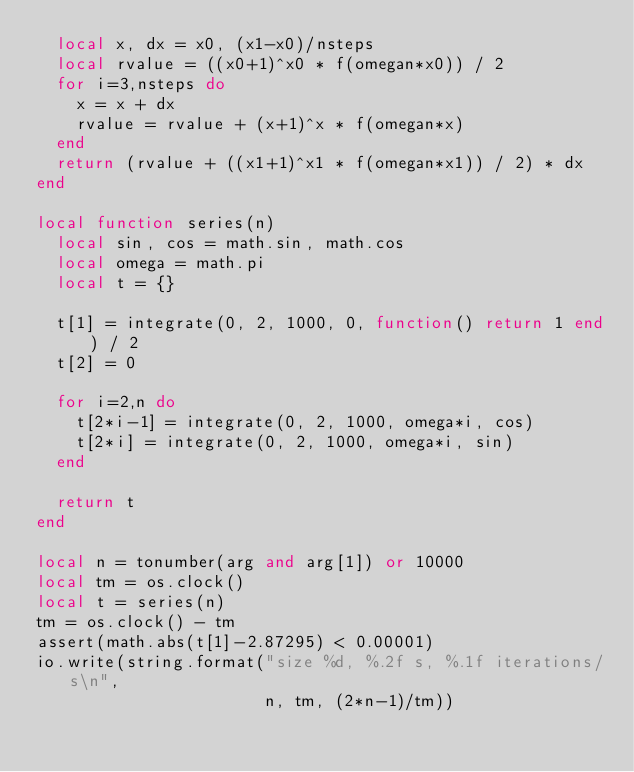<code> <loc_0><loc_0><loc_500><loc_500><_Lua_>  local x, dx = x0, (x1-x0)/nsteps
  local rvalue = ((x0+1)^x0 * f(omegan*x0)) / 2
  for i=3,nsteps do
    x = x + dx
    rvalue = rvalue + (x+1)^x * f(omegan*x)
  end
  return (rvalue + ((x1+1)^x1 * f(omegan*x1)) / 2) * dx
end

local function series(n)
  local sin, cos = math.sin, math.cos
  local omega = math.pi
  local t = {}

  t[1] = integrate(0, 2, 1000, 0, function() return 1 end) / 2
  t[2] = 0

  for i=2,n do
    t[2*i-1] = integrate(0, 2, 1000, omega*i, cos)
    t[2*i] = integrate(0, 2, 1000, omega*i, sin)
  end

  return t
end

local n = tonumber(arg and arg[1]) or 10000
local tm = os.clock()
local t = series(n)
tm = os.clock() - tm
assert(math.abs(t[1]-2.87295) < 0.00001)
io.write(string.format("size %d, %.2f s, %.1f iterations/s\n",
                       n, tm, (2*n-1)/tm))
</code> 